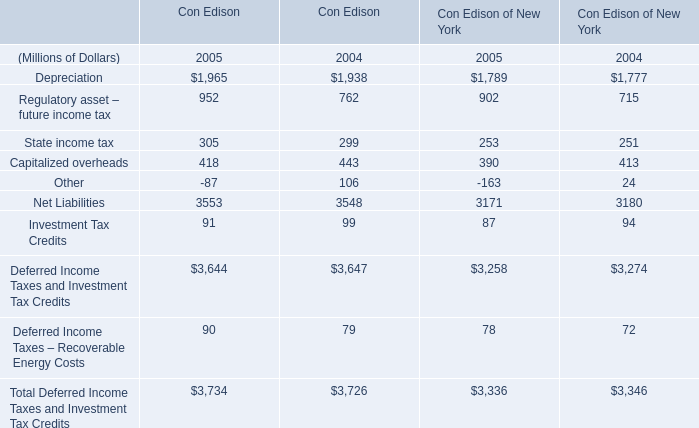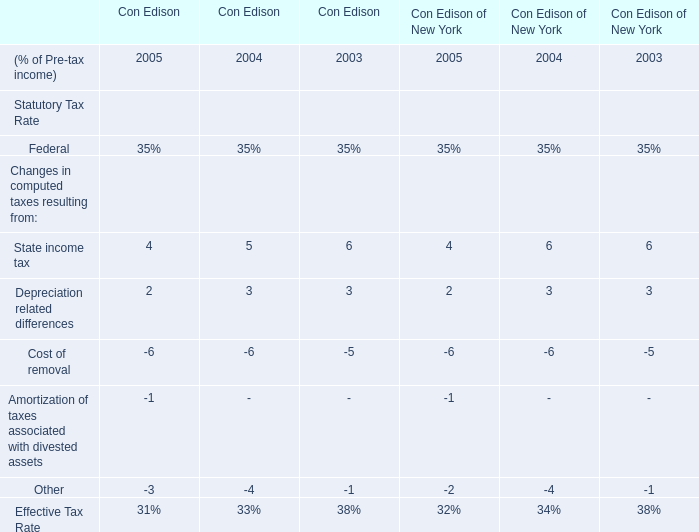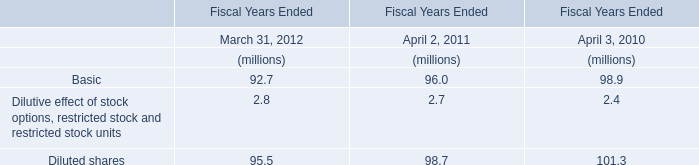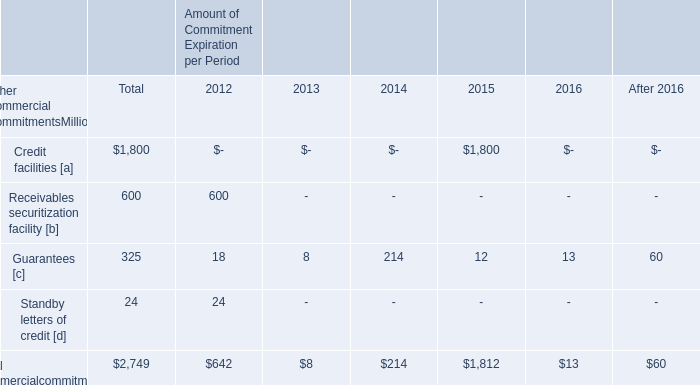What is the sum of Net Liabilities of Con Edison in 2004 and Basic in 2011? (in million) 
Computations: (3548 + 96)
Answer: 3644.0. 